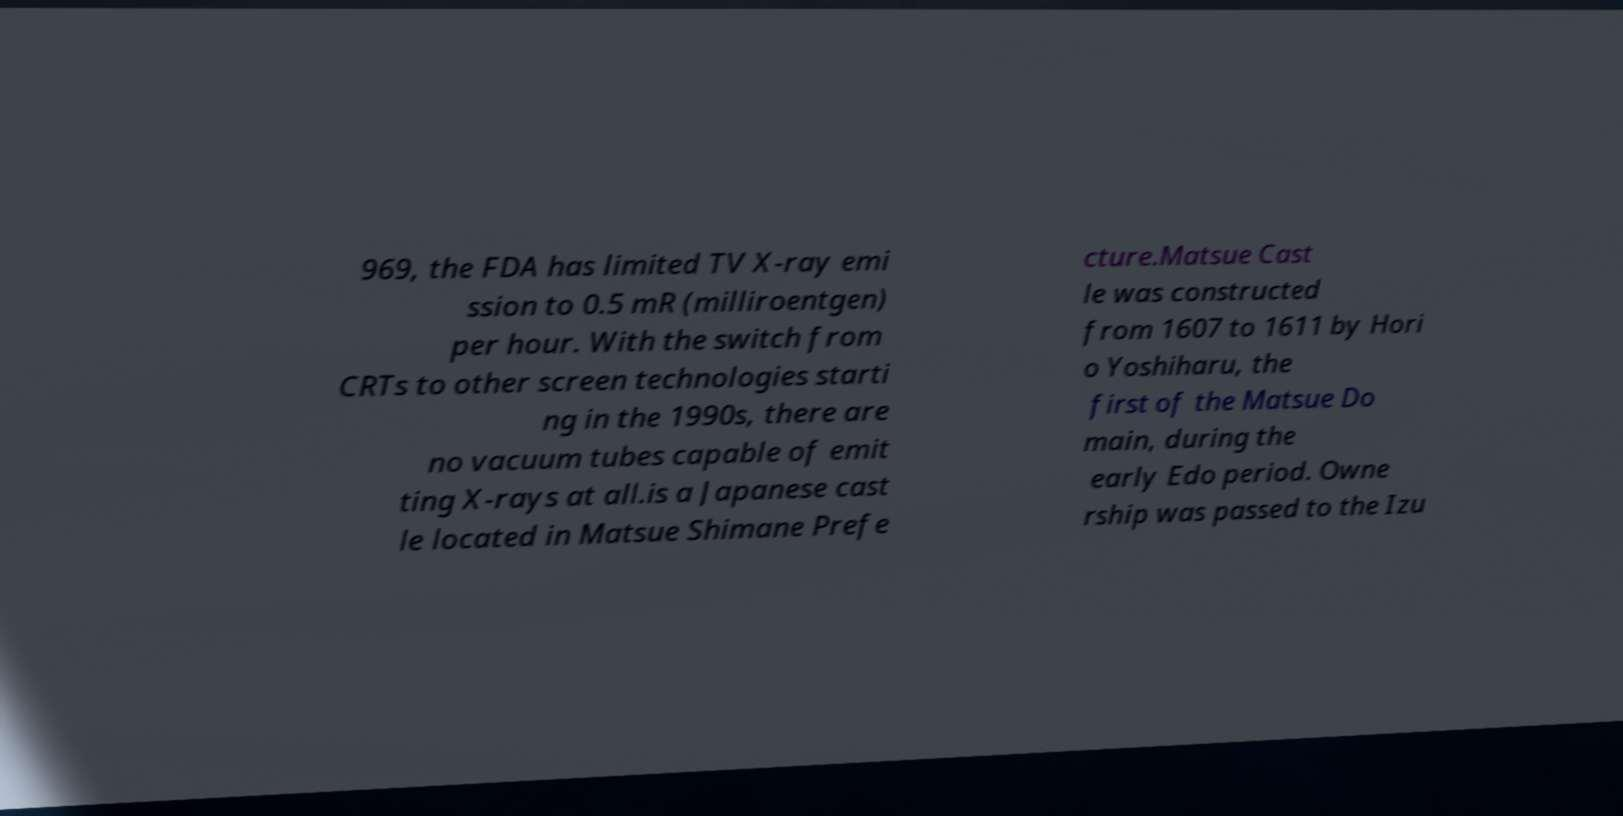Can you accurately transcribe the text from the provided image for me? 969, the FDA has limited TV X-ray emi ssion to 0.5 mR (milliroentgen) per hour. With the switch from CRTs to other screen technologies starti ng in the 1990s, there are no vacuum tubes capable of emit ting X-rays at all.is a Japanese cast le located in Matsue Shimane Prefe cture.Matsue Cast le was constructed from 1607 to 1611 by Hori o Yoshiharu, the first of the Matsue Do main, during the early Edo period. Owne rship was passed to the Izu 